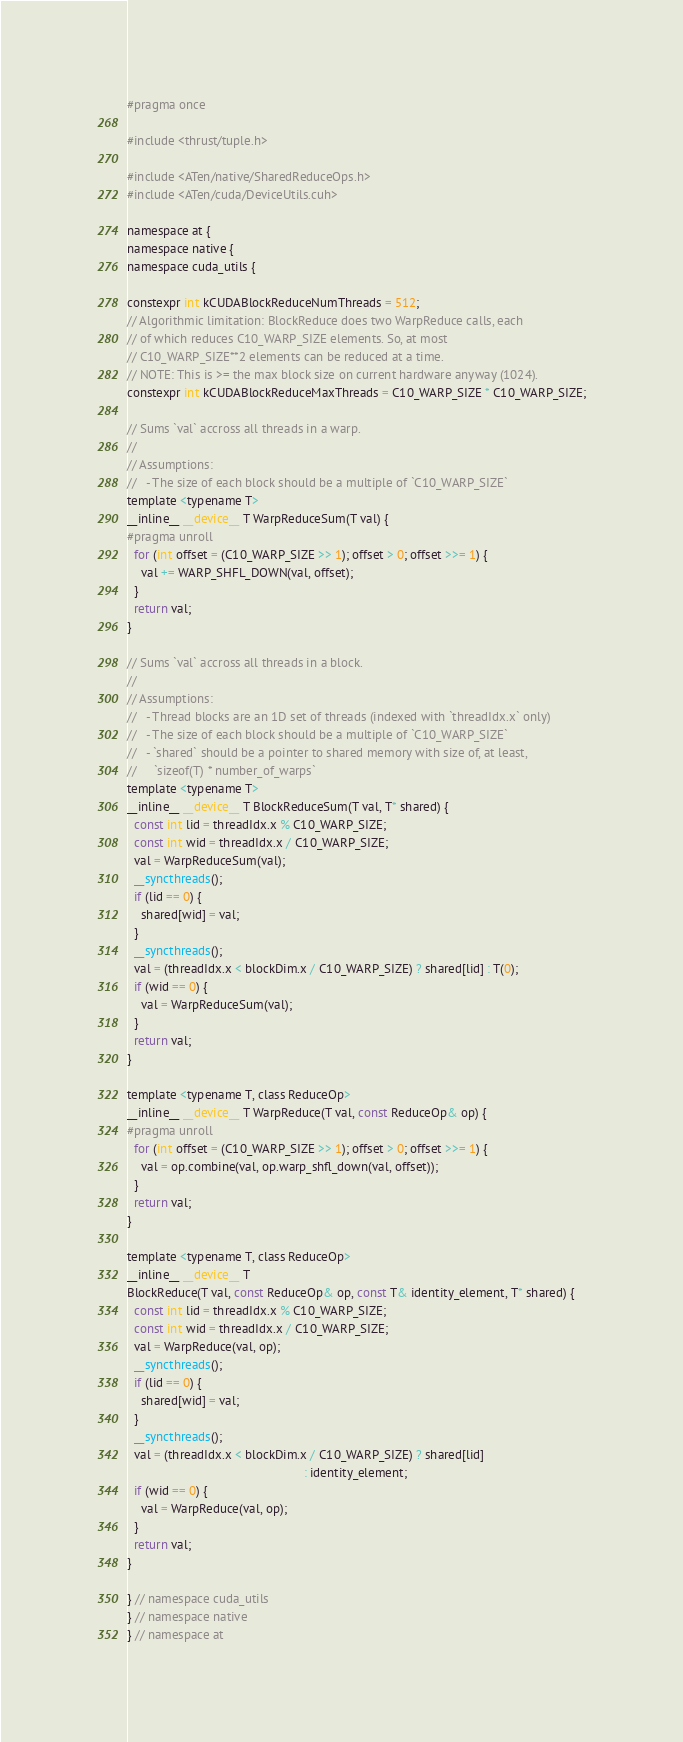Convert code to text. <code><loc_0><loc_0><loc_500><loc_500><_Cuda_>#pragma once

#include <thrust/tuple.h>

#include <ATen/native/SharedReduceOps.h>
#include <ATen/cuda/DeviceUtils.cuh>

namespace at {
namespace native {
namespace cuda_utils {

constexpr int kCUDABlockReduceNumThreads = 512;
// Algorithmic limitation: BlockReduce does two WarpReduce calls, each
// of which reduces C10_WARP_SIZE elements. So, at most
// C10_WARP_SIZE**2 elements can be reduced at a time.
// NOTE: This is >= the max block size on current hardware anyway (1024).
constexpr int kCUDABlockReduceMaxThreads = C10_WARP_SIZE * C10_WARP_SIZE;

// Sums `val` accross all threads in a warp.
//
// Assumptions:
//   - The size of each block should be a multiple of `C10_WARP_SIZE`
template <typename T>
__inline__ __device__ T WarpReduceSum(T val) {
#pragma unroll
  for (int offset = (C10_WARP_SIZE >> 1); offset > 0; offset >>= 1) {
    val += WARP_SHFL_DOWN(val, offset);
  }
  return val;
}

// Sums `val` accross all threads in a block.
//
// Assumptions:
//   - Thread blocks are an 1D set of threads (indexed with `threadIdx.x` only)
//   - The size of each block should be a multiple of `C10_WARP_SIZE`
//   - `shared` should be a pointer to shared memory with size of, at least,
//     `sizeof(T) * number_of_warps`
template <typename T>
__inline__ __device__ T BlockReduceSum(T val, T* shared) {
  const int lid = threadIdx.x % C10_WARP_SIZE;
  const int wid = threadIdx.x / C10_WARP_SIZE;
  val = WarpReduceSum(val);
  __syncthreads();
  if (lid == 0) {
    shared[wid] = val;
  }
  __syncthreads();
  val = (threadIdx.x < blockDim.x / C10_WARP_SIZE) ? shared[lid] : T(0);
  if (wid == 0) {
    val = WarpReduceSum(val);
  }
  return val;
}

template <typename T, class ReduceOp>
__inline__ __device__ T WarpReduce(T val, const ReduceOp& op) {
#pragma unroll
  for (int offset = (C10_WARP_SIZE >> 1); offset > 0; offset >>= 1) {
    val = op.combine(val, op.warp_shfl_down(val, offset));
  }
  return val;
}

template <typename T, class ReduceOp>
__inline__ __device__ T
BlockReduce(T val, const ReduceOp& op, const T& identity_element, T* shared) {
  const int lid = threadIdx.x % C10_WARP_SIZE;
  const int wid = threadIdx.x / C10_WARP_SIZE;
  val = WarpReduce(val, op);
  __syncthreads();
  if (lid == 0) {
    shared[wid] = val;
  }
  __syncthreads();
  val = (threadIdx.x < blockDim.x / C10_WARP_SIZE) ? shared[lid]
                                                   : identity_element;
  if (wid == 0) {
    val = WarpReduce(val, op);
  }
  return val;
}

} // namespace cuda_utils
} // namespace native
} // namespace at
</code> 